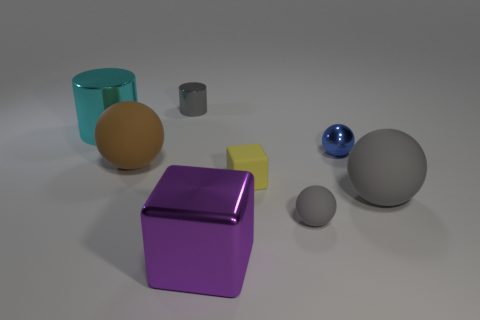The tiny metal ball is what color?
Offer a very short reply. Blue. Are there any metal objects of the same color as the tiny metallic sphere?
Your response must be concise. No. Is the color of the big matte ball that is right of the brown matte thing the same as the shiny cube?
Provide a short and direct response. No. What number of objects are either large matte objects right of the small gray matte sphere or cyan matte cylinders?
Your answer should be very brief. 1. Are there any gray things right of the tiny yellow thing?
Keep it short and to the point. Yes. There is a big sphere that is the same color as the tiny rubber ball; what is its material?
Keep it short and to the point. Rubber. Is the material of the large thing in front of the tiny gray rubber thing the same as the cyan object?
Your response must be concise. Yes. There is a large thing to the right of the tiny gray object to the right of the large metallic block; is there a cyan object that is in front of it?
Your answer should be compact. No. What number of cylinders are either small gray objects or tiny blue objects?
Your response must be concise. 1. What is the material of the small gray thing on the right side of the large purple cube?
Provide a succinct answer. Rubber. 